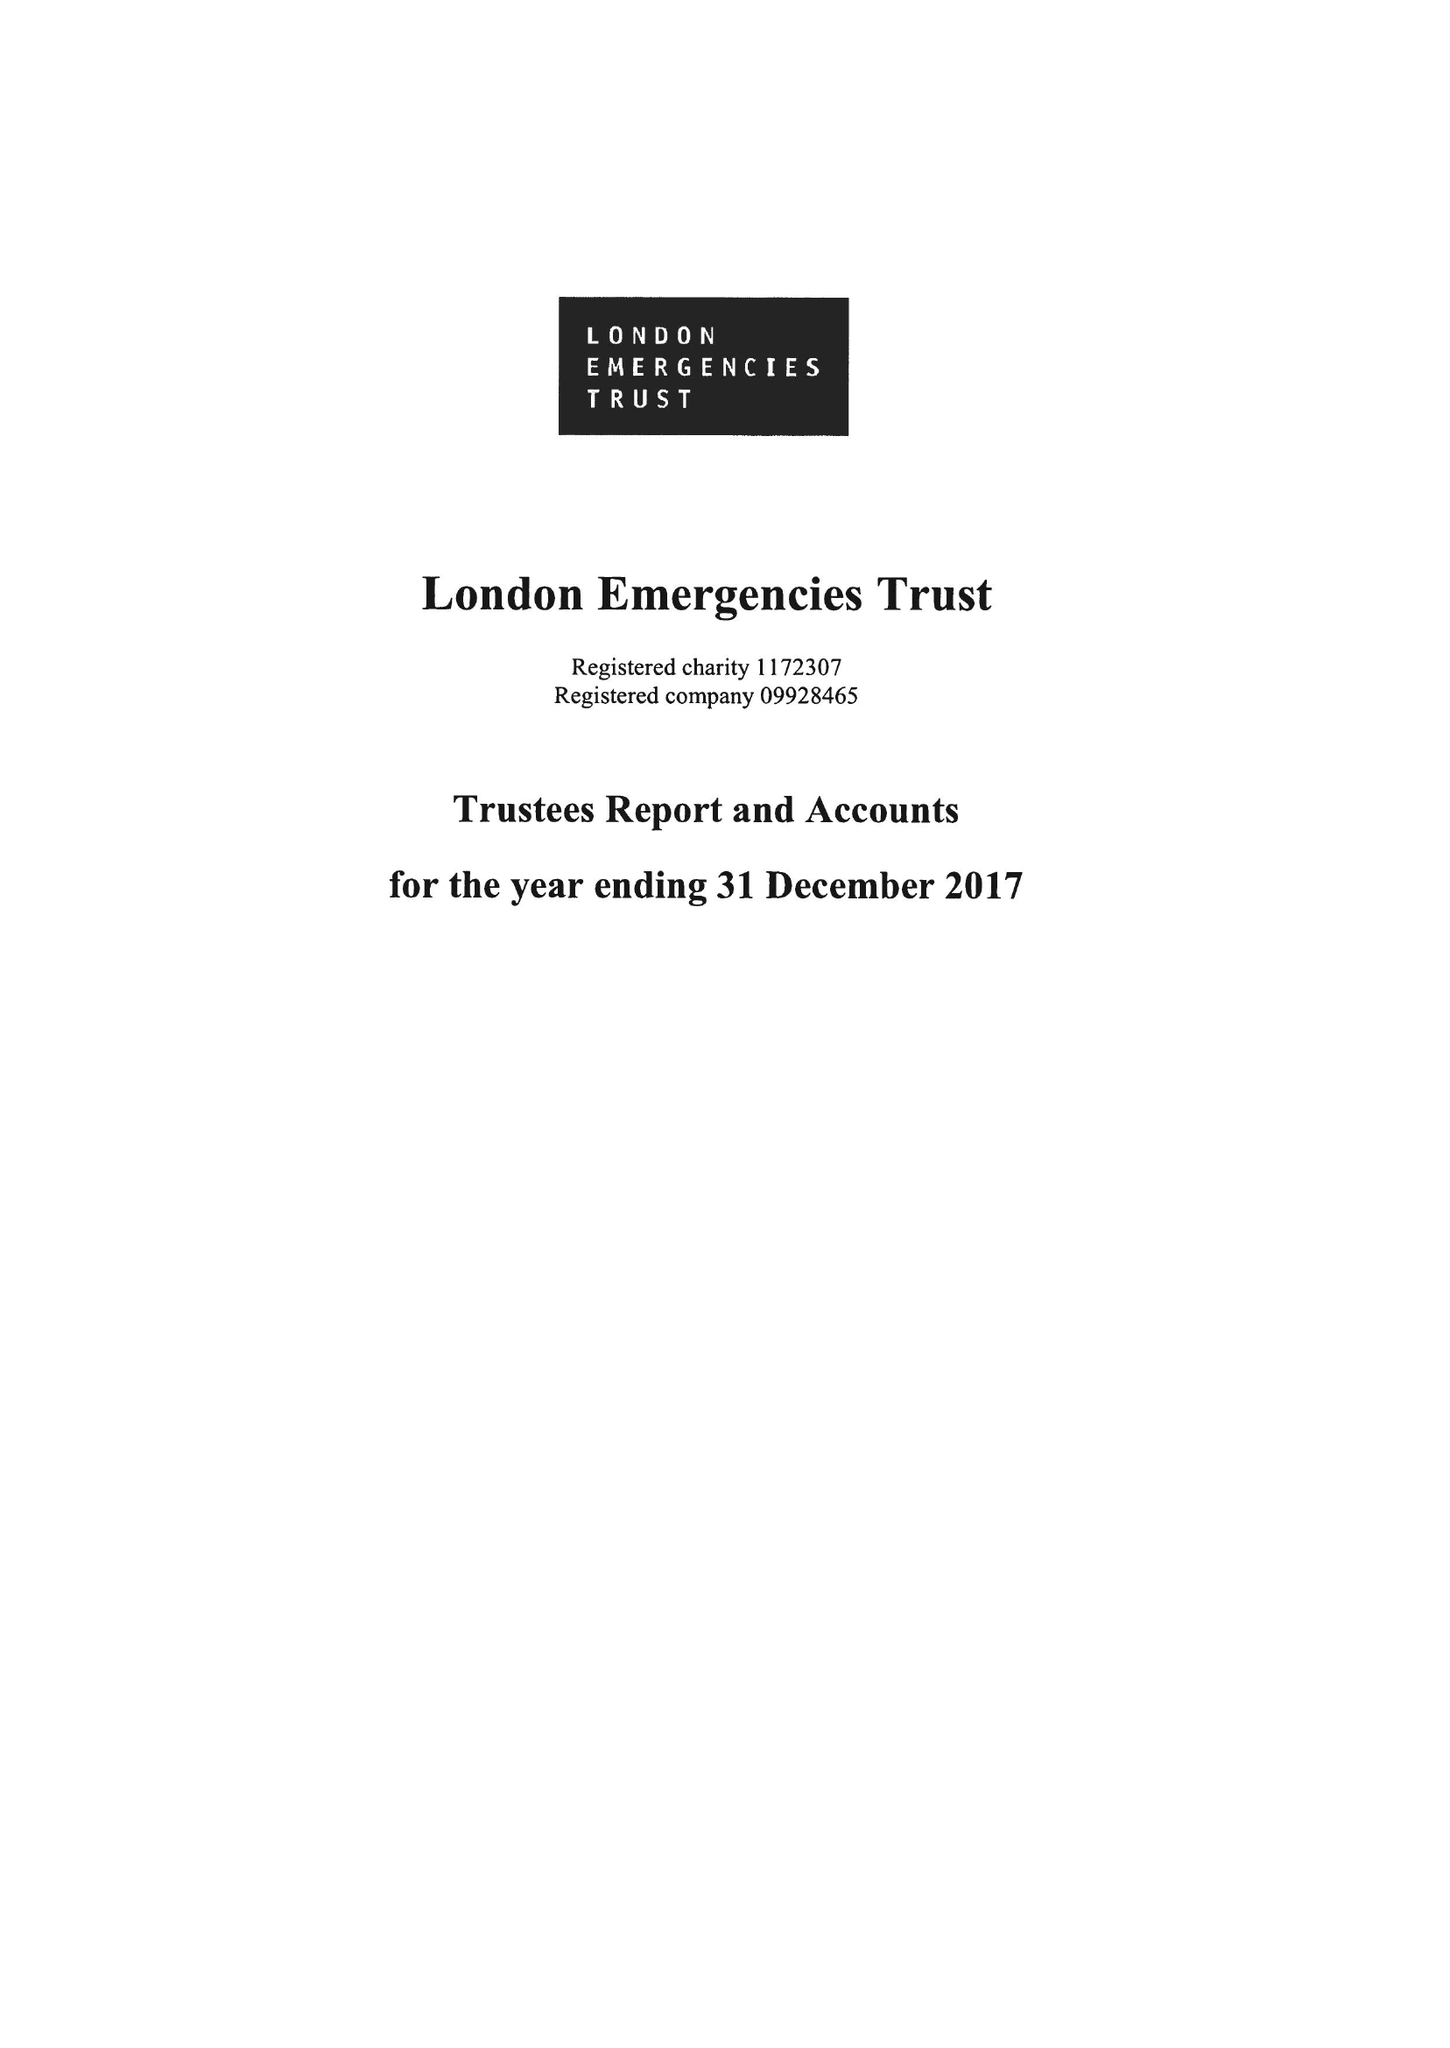What is the value for the address__post_town?
Answer the question using a single word or phrase. LONDON 